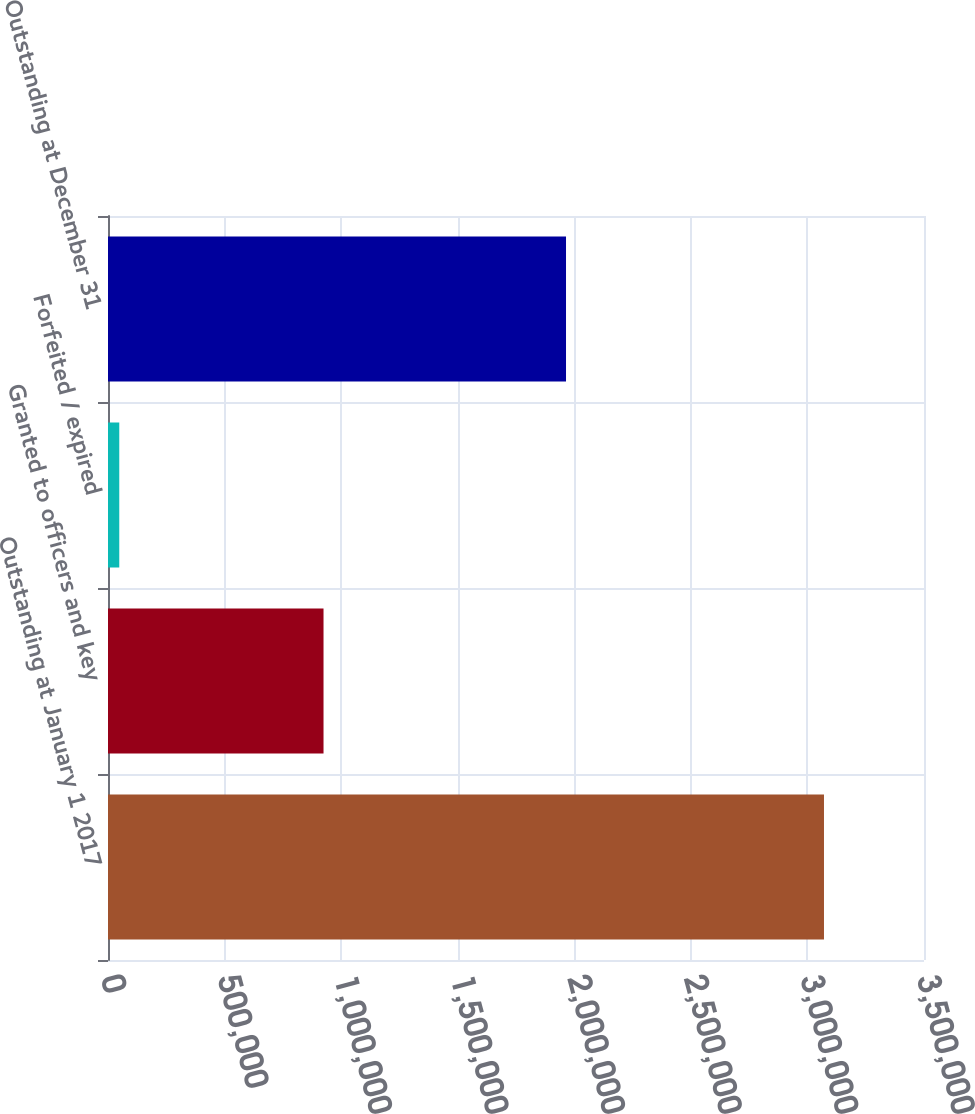Convert chart to OTSL. <chart><loc_0><loc_0><loc_500><loc_500><bar_chart><fcel>Outstanding at January 1 2017<fcel>Granted to officers and key<fcel>Forfeited / expired<fcel>Outstanding at December 31<nl><fcel>3.07101e+06<fcel>924421<fcel>48353<fcel>1.96452e+06<nl></chart> 